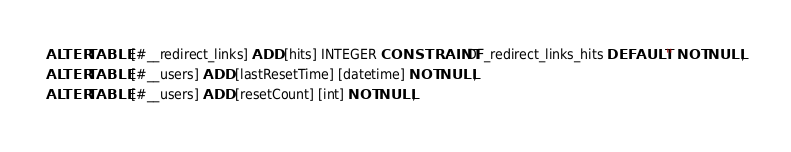<code> <loc_0><loc_0><loc_500><loc_500><_SQL_>ALTER TABLE [#__redirect_links] ADD [hits] INTEGER CONSTRAINT DF_redirect_links_hits DEFAULT '' NOT NULL;
ALTER TABLE [#__users] ADD [lastResetTime] [datetime] NOT NULL;
ALTER TABLE [#__users] ADD [resetCount] [int] NOT NULL;</code> 